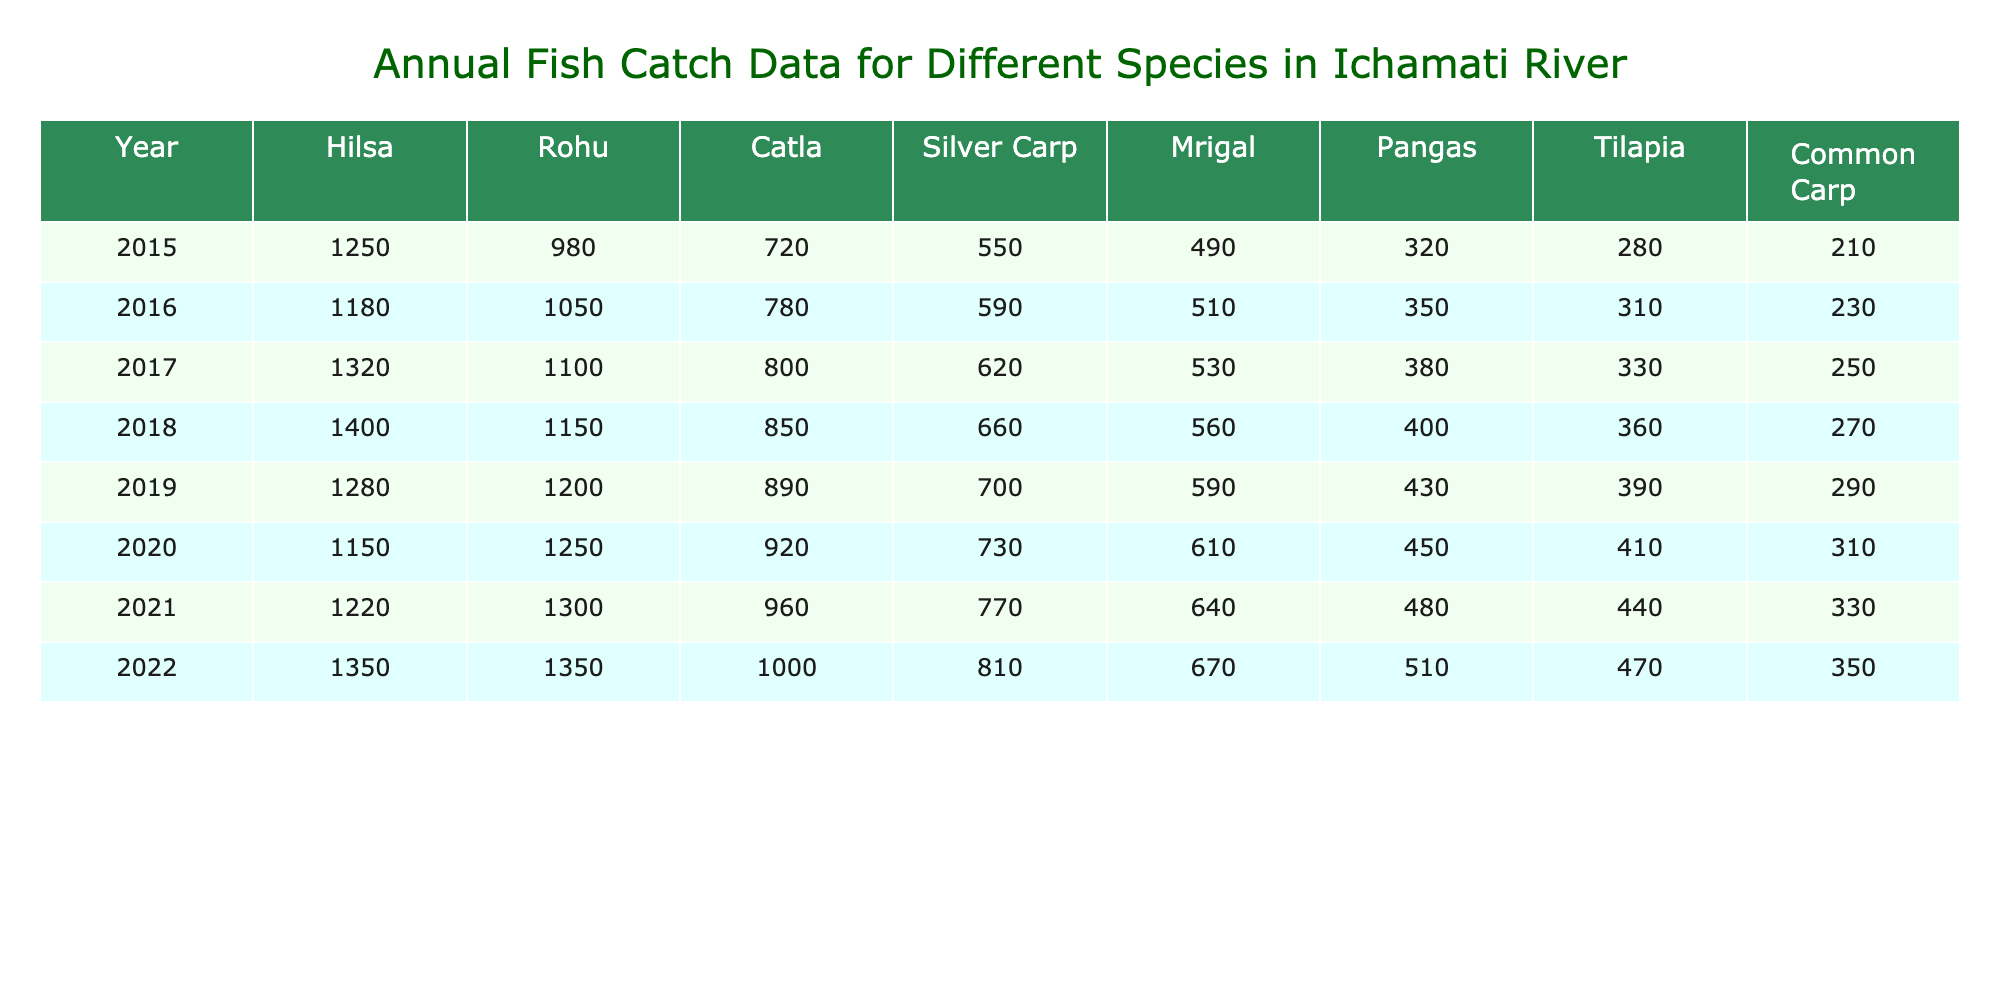What was the highest fish catch for Hilsa in a single year? In the table, I look through the Hilsa column for the maximum value. The highest value appears in 2018 with 1400.
Answer: 1400 In which year was the fish catch for Rohu the highest? By examining the Rohu column, I see that the highest value is in 2021 with 1300.
Answer: 2021 What is the total fish catch for Catla across all years? I sum all the values in the Catla column: 720 + 780 + 800 + 850 + 890 + 920 + 960 + 1000 = 5,520.
Answer: 5520 Which species had the lowest total catch over the 8 years? I sum the values for each species and find that Pangas has a total of 3,370, which is less than the totals for all the others, indicating it's the lowest.
Answer: Pangas Was the fish catch of Silver Carp increasing every year? I look at the Silver Carp column values from each year, 550, 590, 620, 660, 700, 730, 770, 810. All values increase, confirming that the catch was increasing each year.
Answer: Yes What was the difference in catch between Mrigal in 2015 and 2022? I pull the values from the Mrigal column: in 2015, the catch was 490, and in 2022, it was 670. The difference is 670 - 490 = 180.
Answer: 180 What was the average catch for Tilapia from 2015 to 2022? I sum the Tilapia catches: 280 + 310 + 330 + 360 + 390 + 410 + 440 + 470 = 2,590, and divide by 8 (the number of years): 2,590 / 8 = 323.75.
Answer: 323.75 Which species consistently had the highest catch from 2015 to 2022? By reviewing the highest values for each year, Hilsa is consistently the highest for every year, indicating it had the highest catch.
Answer: Hilsa Was there a year when the common carp catch exceeded 300? I check the Common Carp column: only in 2020 (310), 2021 (330), and 2022 (350) does the catch exceed 300, confirming there were multiple such years.
Answer: Yes What is the trend of total fish catch from 2015 to 2022? I analyze the yearly totals, finding an overall increase from 2015 (6,556) to 2022 (7,710), suggesting a positive trend over the years.
Answer: Increasing 